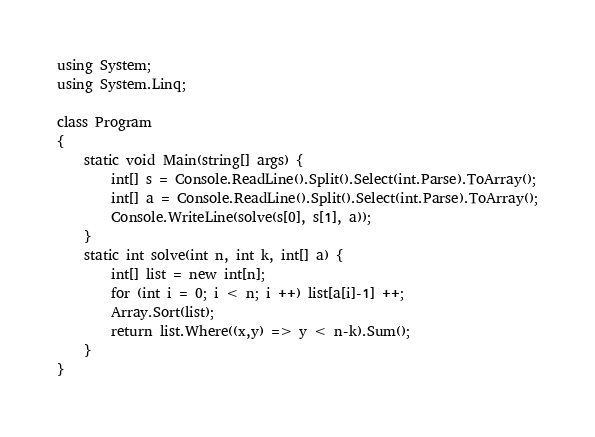<code> <loc_0><loc_0><loc_500><loc_500><_C#_>using System;
using System.Linq;

class Program
{
    static void Main(string[] args) {
        int[] s = Console.ReadLine().Split().Select(int.Parse).ToArray();
        int[] a = Console.ReadLine().Split().Select(int.Parse).ToArray();
        Console.WriteLine(solve(s[0], s[1], a));
    }
    static int solve(int n, int k, int[] a) {
        int[] list = new int[n];
        for (int i = 0; i < n; i ++) list[a[i]-1] ++;
        Array.Sort(list);
        return list.Where((x,y) => y < n-k).Sum();
    }
}</code> 